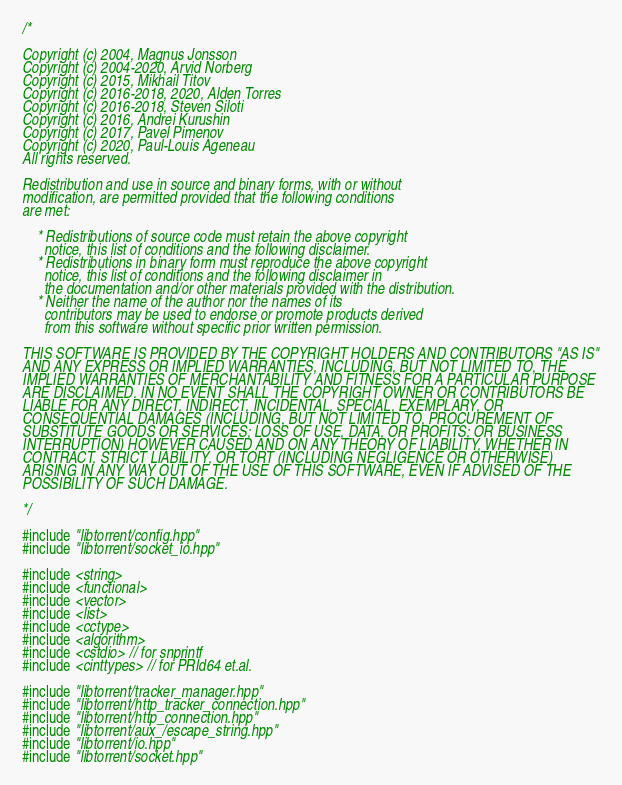<code> <loc_0><loc_0><loc_500><loc_500><_C++_>/*

Copyright (c) 2004, Magnus Jonsson
Copyright (c) 2004-2020, Arvid Norberg
Copyright (c) 2015, Mikhail Titov
Copyright (c) 2016-2018, 2020, Alden Torres
Copyright (c) 2016-2018, Steven Siloti
Copyright (c) 2016, Andrei Kurushin
Copyright (c) 2017, Pavel Pimenov
Copyright (c) 2020, Paul-Louis Ageneau
All rights reserved.

Redistribution and use in source and binary forms, with or without
modification, are permitted provided that the following conditions
are met:

    * Redistributions of source code must retain the above copyright
      notice, this list of conditions and the following disclaimer.
    * Redistributions in binary form must reproduce the above copyright
      notice, this list of conditions and the following disclaimer in
      the documentation and/or other materials provided with the distribution.
    * Neither the name of the author nor the names of its
      contributors may be used to endorse or promote products derived
      from this software without specific prior written permission.

THIS SOFTWARE IS PROVIDED BY THE COPYRIGHT HOLDERS AND CONTRIBUTORS "AS IS"
AND ANY EXPRESS OR IMPLIED WARRANTIES, INCLUDING, BUT NOT LIMITED TO, THE
IMPLIED WARRANTIES OF MERCHANTABILITY AND FITNESS FOR A PARTICULAR PURPOSE
ARE DISCLAIMED. IN NO EVENT SHALL THE COPYRIGHT OWNER OR CONTRIBUTORS BE
LIABLE FOR ANY DIRECT, INDIRECT, INCIDENTAL, SPECIAL, EXEMPLARY, OR
CONSEQUENTIAL DAMAGES (INCLUDING, BUT NOT LIMITED TO, PROCUREMENT OF
SUBSTITUTE GOODS OR SERVICES; LOSS OF USE, DATA, OR PROFITS; OR BUSINESS
INTERRUPTION) HOWEVER CAUSED AND ON ANY THEORY OF LIABILITY, WHETHER IN
CONTRACT, STRICT LIABILITY, OR TORT (INCLUDING NEGLIGENCE OR OTHERWISE)
ARISING IN ANY WAY OUT OF THE USE OF THIS SOFTWARE, EVEN IF ADVISED OF THE
POSSIBILITY OF SUCH DAMAGE.

*/

#include "libtorrent/config.hpp"
#include "libtorrent/socket_io.hpp"

#include <string>
#include <functional>
#include <vector>
#include <list>
#include <cctype>
#include <algorithm>
#include <cstdio> // for snprintf
#include <cinttypes> // for PRId64 et.al.

#include "libtorrent/tracker_manager.hpp"
#include "libtorrent/http_tracker_connection.hpp"
#include "libtorrent/http_connection.hpp"
#include "libtorrent/aux_/escape_string.hpp"
#include "libtorrent/io.hpp"
#include "libtorrent/socket.hpp"</code> 